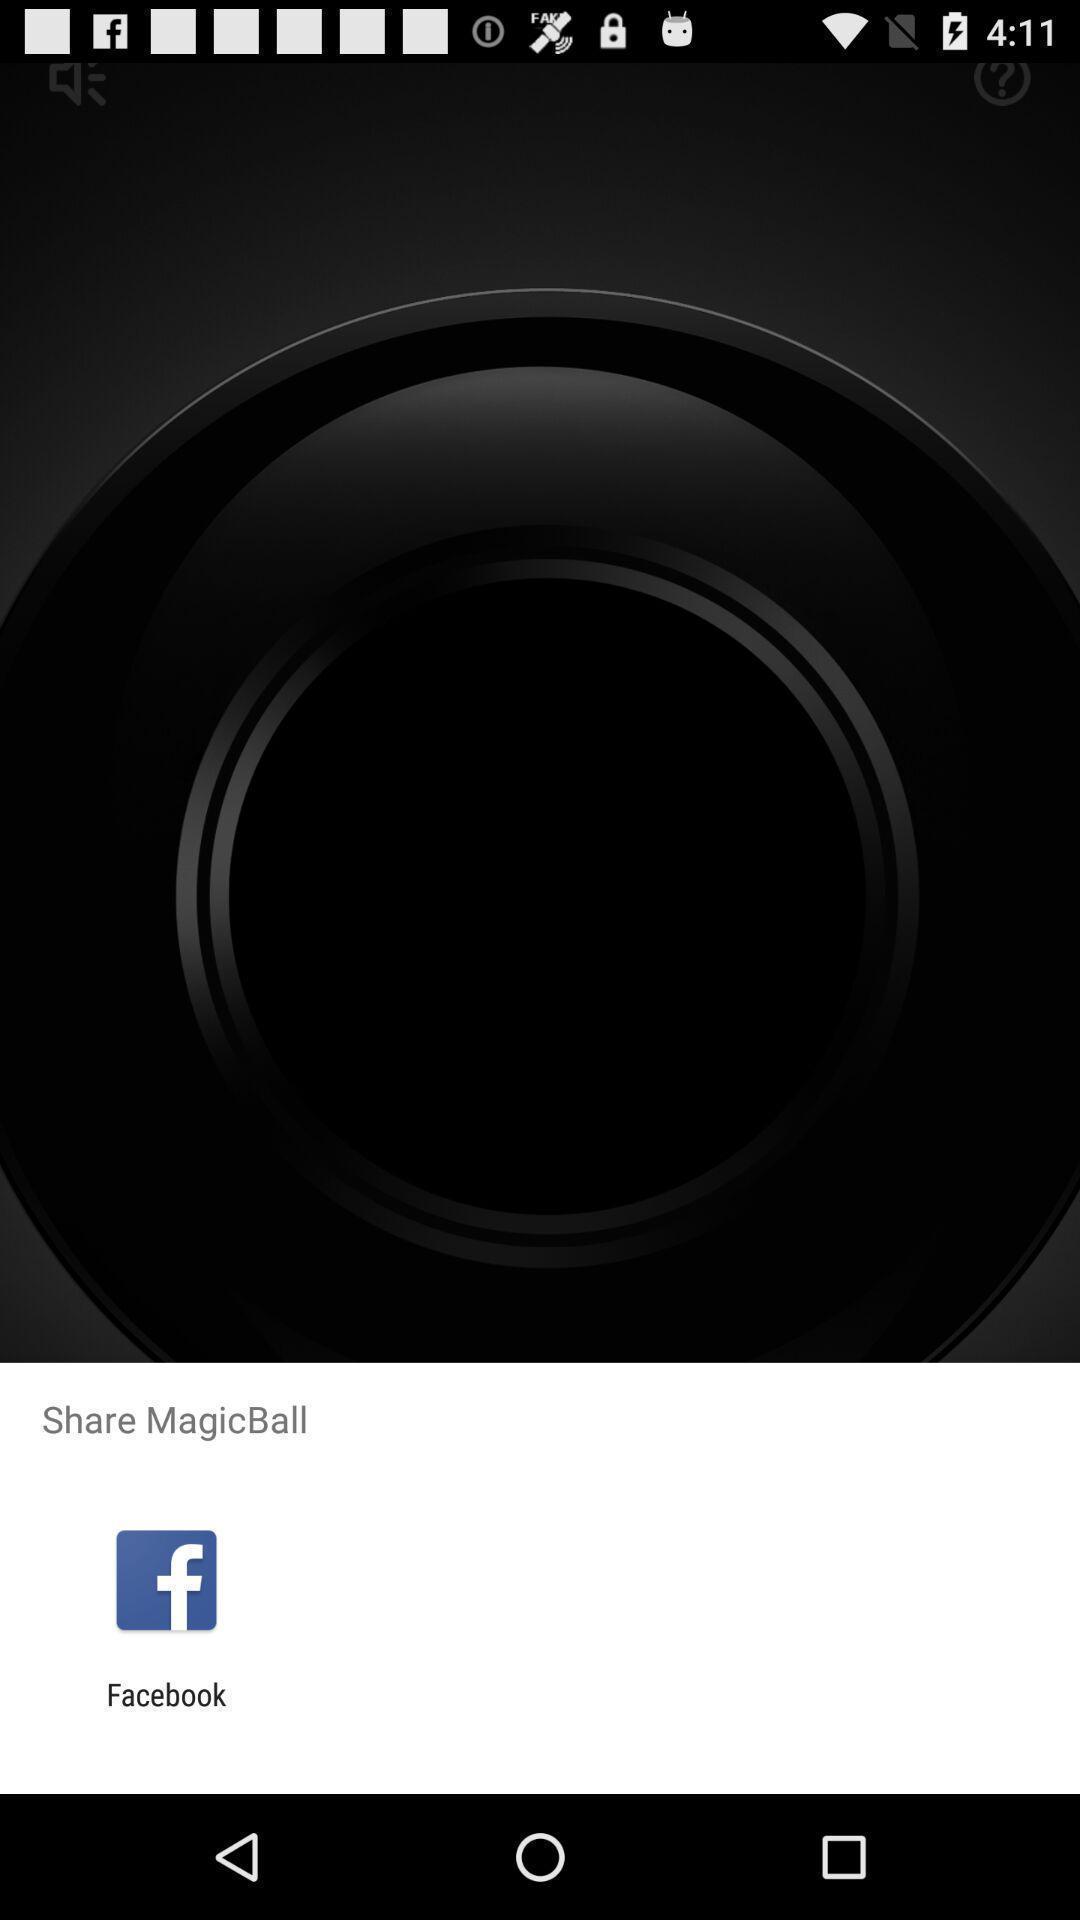What details can you identify in this image? Popup showing a share option with icon. 